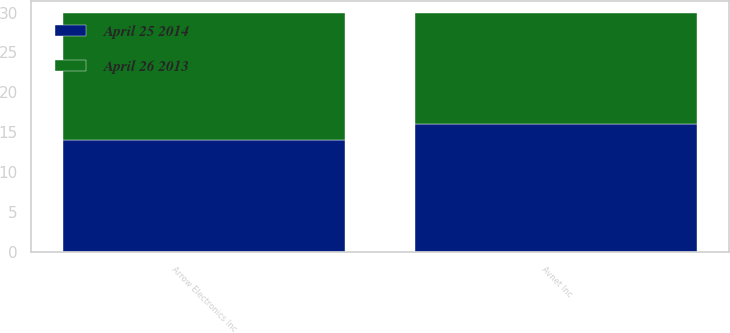Convert chart to OTSL. <chart><loc_0><loc_0><loc_500><loc_500><stacked_bar_chart><ecel><fcel>Arrow Electronics Inc<fcel>Avnet Inc<nl><fcel>April 25 2014<fcel>14<fcel>16<nl><fcel>April 26 2013<fcel>16<fcel>14<nl></chart> 